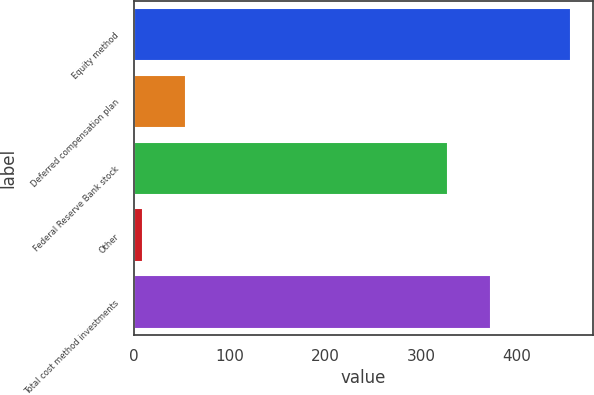<chart> <loc_0><loc_0><loc_500><loc_500><bar_chart><fcel>Equity method<fcel>Deferred compensation plan<fcel>Federal Reserve Bank stock<fcel>Other<fcel>Total cost method investments<nl><fcel>457<fcel>53.8<fcel>328<fcel>9<fcel>372.8<nl></chart> 